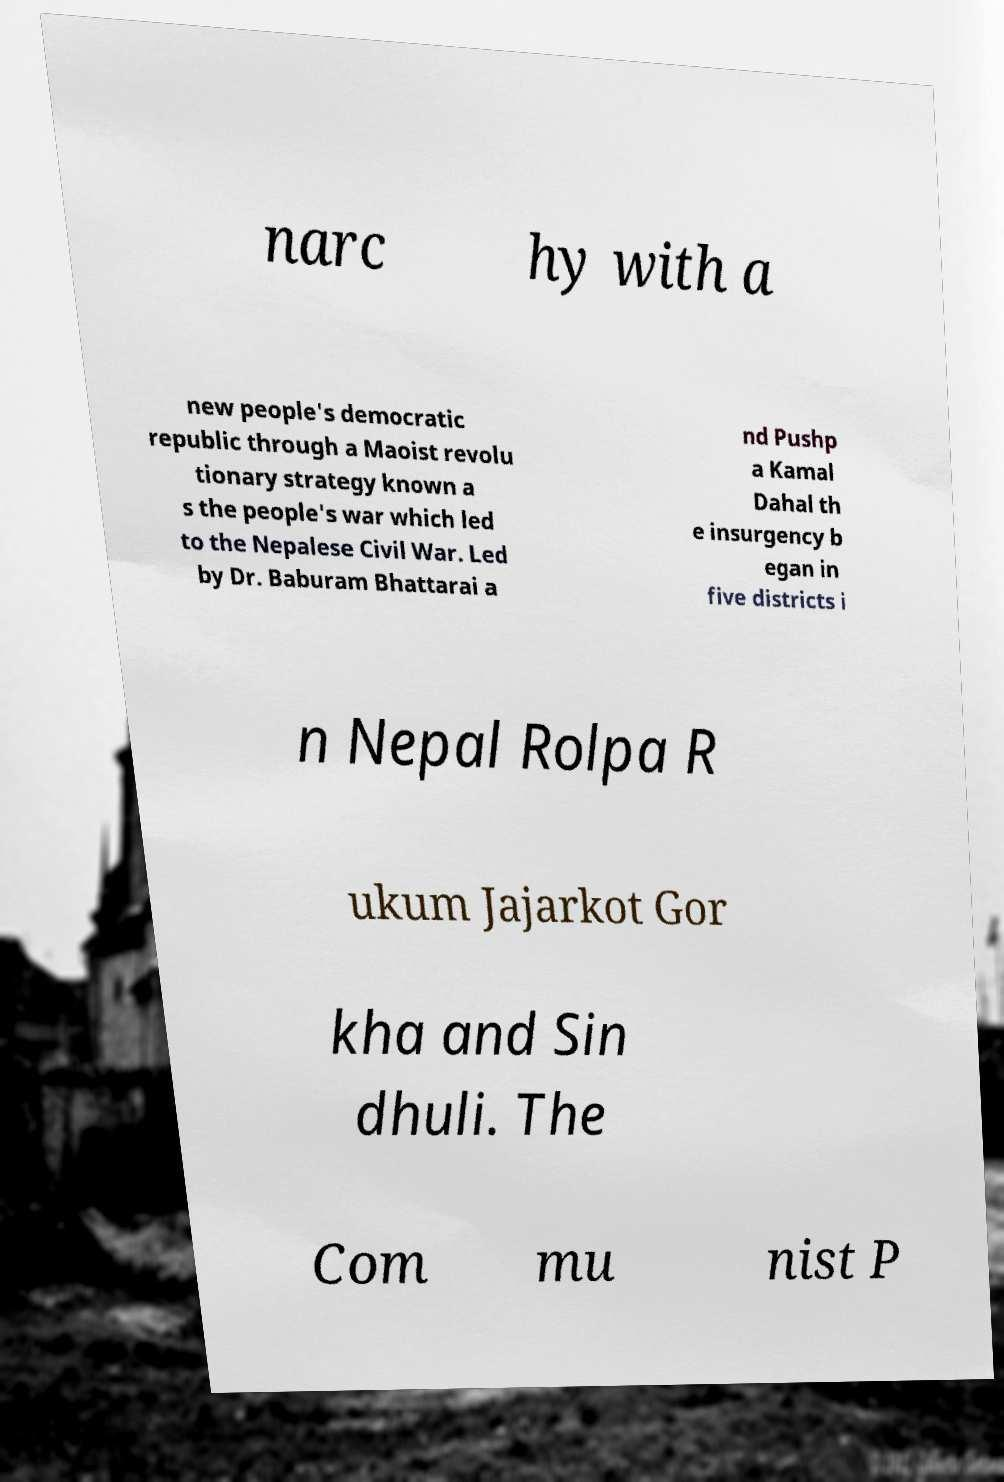What messages or text are displayed in this image? I need them in a readable, typed format. narc hy with a new people's democratic republic through a Maoist revolu tionary strategy known a s the people's war which led to the Nepalese Civil War. Led by Dr. Baburam Bhattarai a nd Pushp a Kamal Dahal th e insurgency b egan in five districts i n Nepal Rolpa R ukum Jajarkot Gor kha and Sin dhuli. The Com mu nist P 